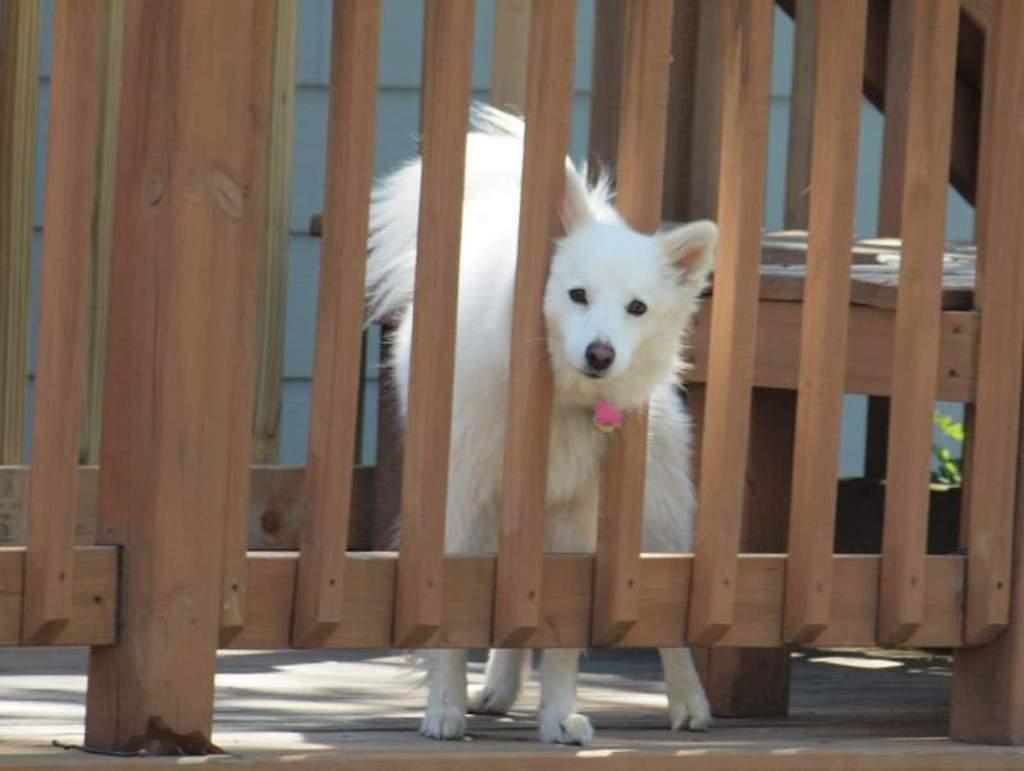Please provide a concise description of this image. In this image I can see wooden fencing in the front and in the centre of the image I can see a white colour dog is standing. On the right side of this image I can see few green colour leaves and I can also see shadows on the ground. 